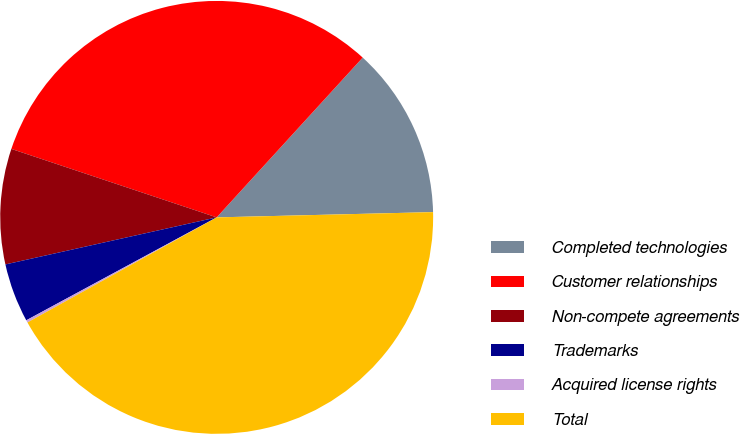Convert chart. <chart><loc_0><loc_0><loc_500><loc_500><pie_chart><fcel>Completed technologies<fcel>Customer relationships<fcel>Non-compete agreements<fcel>Trademarks<fcel>Acquired license rights<fcel>Total<nl><fcel>12.83%<fcel>31.66%<fcel>8.61%<fcel>4.4%<fcel>0.18%<fcel>42.32%<nl></chart> 